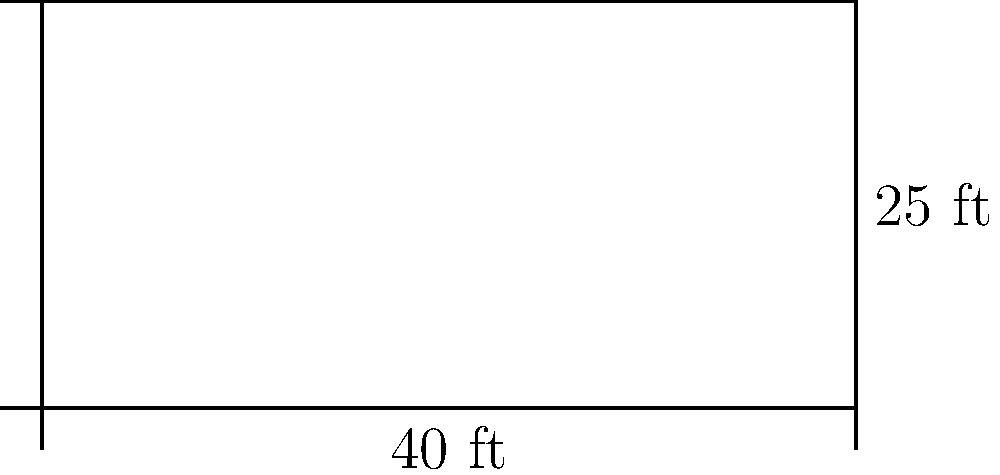A legendary hip hop battle is about to take place on a rectangular dance floor. The floor measures 40 feet in length and 25 feet in width. As a hip hop purist who values the essence of the dance, you need to ensure there's enough space for the dancers to showcase their skills without compromising the traditional cypher format. What is the perimeter of this dance floor? To find the perimeter of the rectangular dance floor, we need to follow these steps:

1. Recall the formula for the perimeter of a rectangle:
   $$ P = 2l + 2w $$
   where $P$ is the perimeter, $l$ is the length, and $w$ is the width.

2. Identify the given dimensions:
   Length ($l$) = 40 feet
   Width ($w$) = 25 feet

3. Substitute these values into the formula:
   $$ P = 2(40) + 2(25) $$

4. Simplify:
   $$ P = 80 + 50 $$

5. Calculate the final result:
   $$ P = 130 $$

Therefore, the perimeter of the dance floor is 130 feet.
Answer: 130 feet 